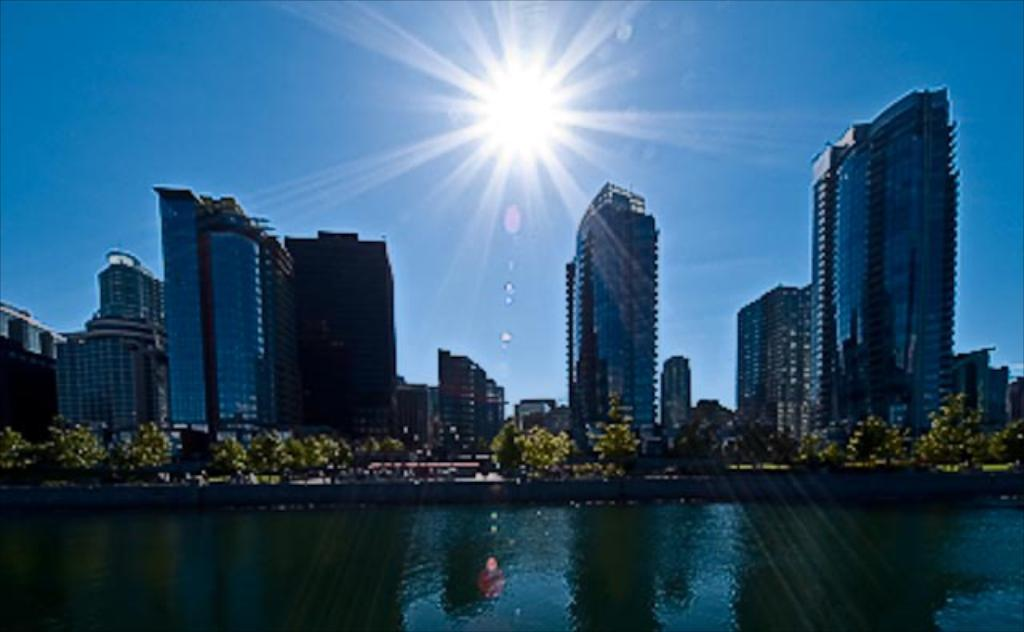What type of structures can be seen in the image? There are buildings in the image. What other natural elements are present in the image? There are trees and water visible in the image. What is visible in the sky in the image? The sun is observable in the image. How is the image quality? The image is slightly blurred. What direction is the bedroom facing in the image? There is no bedroom present in the image. What type of grain can be seen in the image? There is no grain visible in the image. 